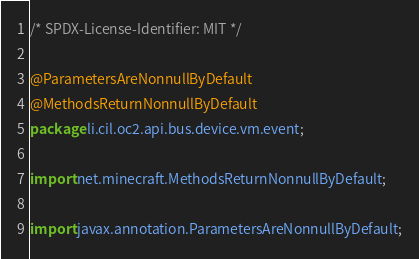Convert code to text. <code><loc_0><loc_0><loc_500><loc_500><_Java_>/* SPDX-License-Identifier: MIT */

@ParametersAreNonnullByDefault
@MethodsReturnNonnullByDefault
package li.cil.oc2.api.bus.device.vm.event;

import net.minecraft.MethodsReturnNonnullByDefault;

import javax.annotation.ParametersAreNonnullByDefault;
</code> 